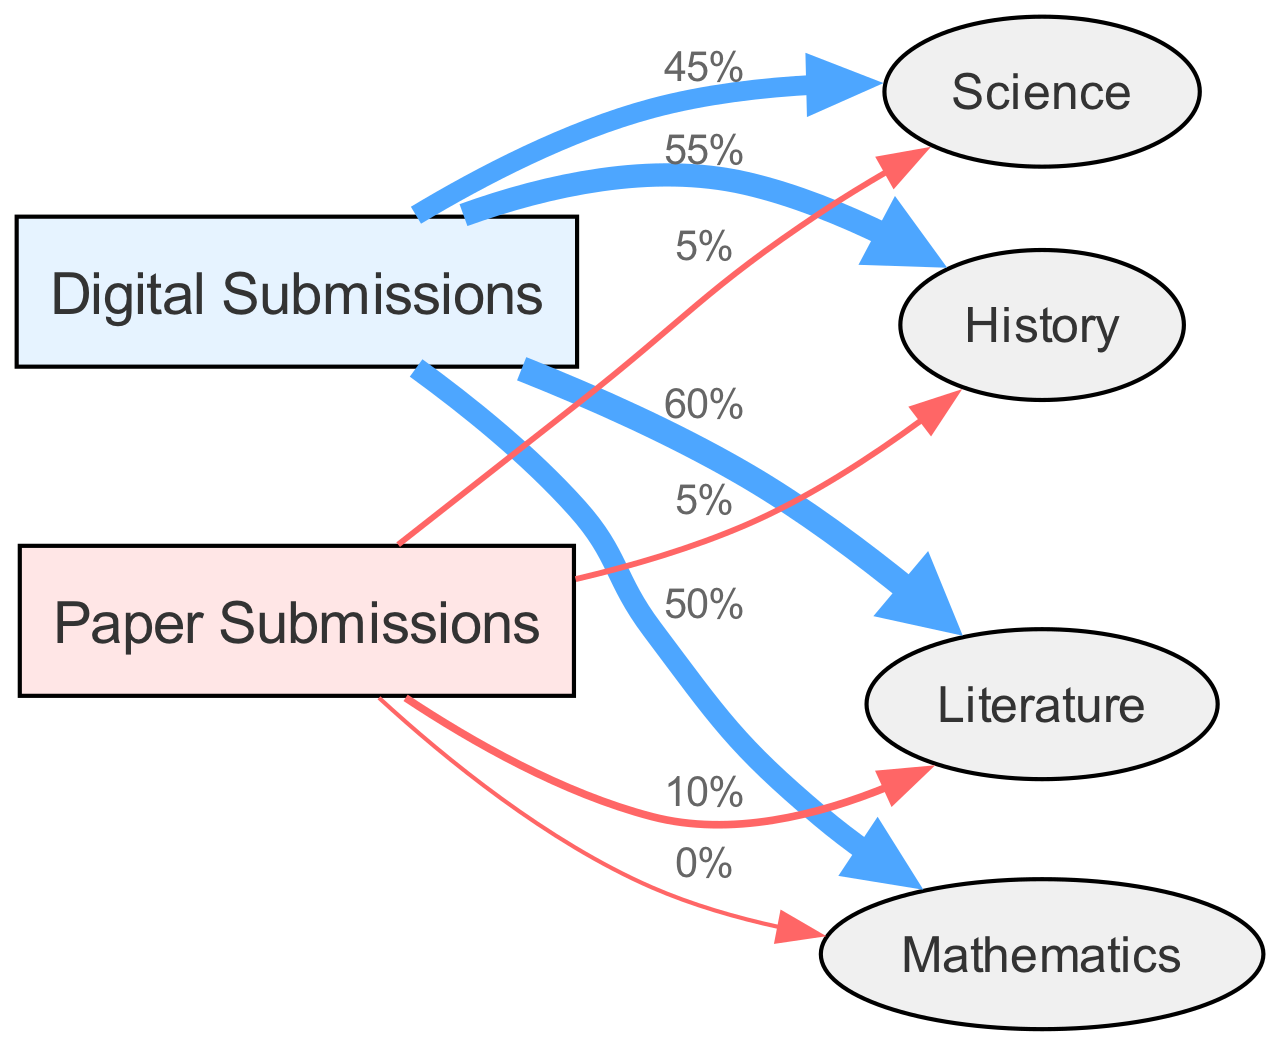What is the percentage of digital submissions for Science? The diagram indicates a flow from "Digital Submissions" to "Science" with a value of 45%, which represents the percentage of digital submissions for this subject area.
Answer: 45% How many total node types are present in the diagram? The diagram includes six nodes: 2 submission formats (Digital and Paper) and 4 subject areas (Science, Mathematics, Literature, History), totaling six types.
Answer: 6 What is the value of paper submissions for Mathematics? The flow from "Paper Submissions" to "Mathematics" shows a value of 0%, indicating that there were no paper submissions for this subject.
Answer: 0% What percentage of Literature submissions are digital? The link from "Digital Submissions" to "Literature" shows a value of 60%, indicating that 60% of submissions for Literature were digital.
Answer: 60% How does the percentage of paper submissions for Science compare to Literature? The percentage of paper submissions for Science is 5% while for Literature, it is 10%. Therefore, Literature has a higher percentage of paper submissions than Science.
Answer: Literature Are there any subjects with only digital submissions? By examining the links, Mathematics shows 0% for paper and 50% for digital, but it does not exclusively have digital submissions as it has paper submissions recorded.
Answer: No What is the total percentage of submissions for digital resources across all subjects? To find the total for digital submissions, we sum the percentages: 45% (Science) + 50% (Mathematics) + 60% (Literature) + 55% (History) = 210%.
Answer: 210% What is the difference in percentage of digital submissions between Literature and History? The percentage for Literature is 60% and for History is 55%. The difference calculation involves subtracting historical submissions from literature submissions: 60% - 55% = 5%.
Answer: 5% Which subject has the highest percentage of digital submissions? Upon reviewing the values, Literature has the highest with 60%, compared to others which have lower percentages.
Answer: Literature 